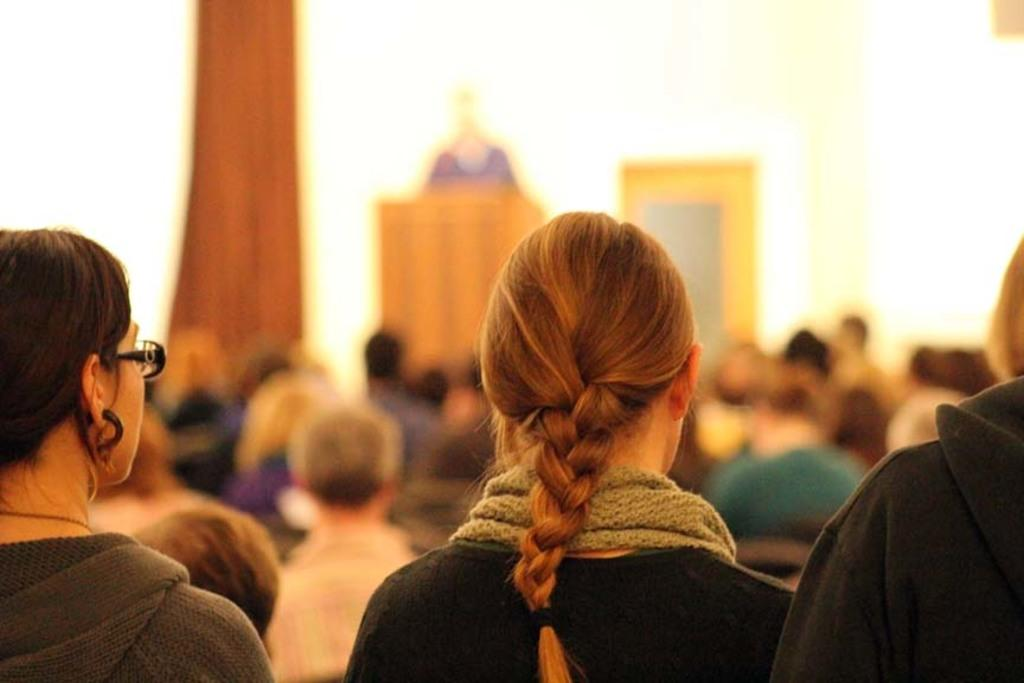What can be seen in the image in terms of people? There are groups of people in the image. What is the color of the wall in the background? The wall in the background is white. What architectural feature is present in the background? There is a door in the background. How would you describe the background in terms of focus? The background appears to be slightly blurred. What is the average income of the people in the image? There is no information about the income of the people in the image, so it cannot be determined. 